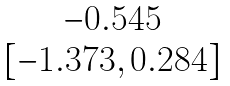<formula> <loc_0><loc_0><loc_500><loc_500>\begin{matrix} - 0 . 5 4 5 \\ [ - 1 . 3 7 3 , 0 . 2 8 4 ] \end{matrix}</formula> 